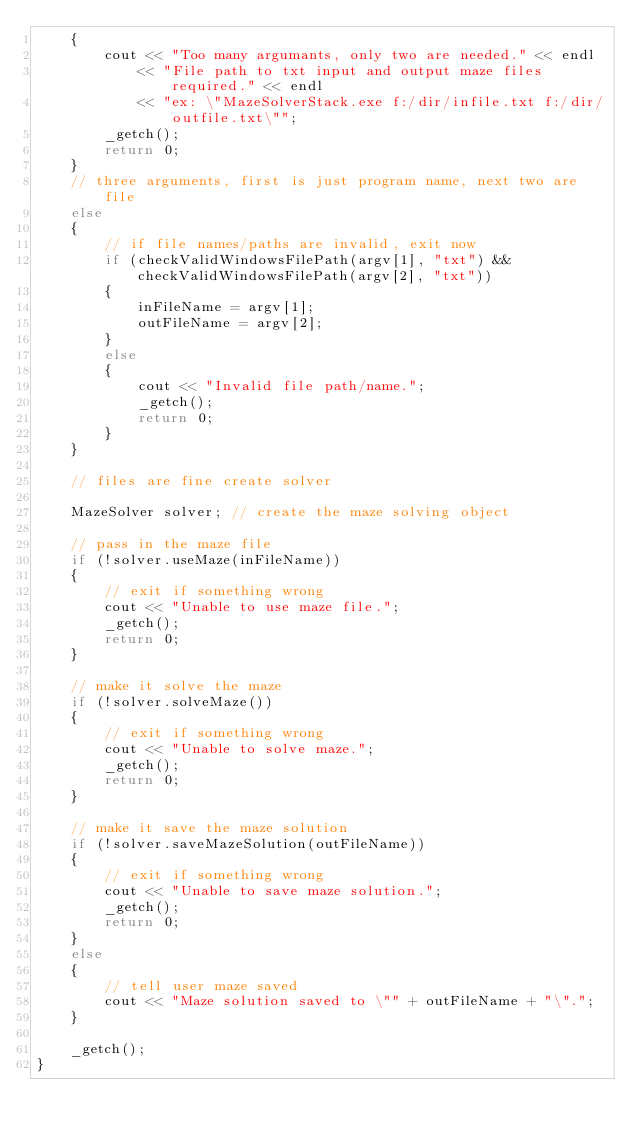<code> <loc_0><loc_0><loc_500><loc_500><_C++_>	{
		cout << "Too many argumants, only two are needed." << endl
			<< "File path to txt input and output maze files required." << endl
			<< "ex: \"MazeSolverStack.exe f:/dir/infile.txt f:/dir/outfile.txt\"";
		_getch();
		return 0;
	}
	// three arguments, first is just program name, next two are file
	else
	{
		// if file names/paths are invalid, exit now
		if (checkValidWindowsFilePath(argv[1], "txt") && checkValidWindowsFilePath(argv[2], "txt"))
		{
			inFileName = argv[1];
			outFileName = argv[2];
		}
		else
		{
			cout << "Invalid file path/name.";
			_getch();
			return 0;
		}
	}

	// files are fine create solver

	MazeSolver solver; // create the maze solving object

	// pass in the maze file
	if (!solver.useMaze(inFileName))
	{
		// exit if something wrong
		cout << "Unable to use maze file.";
		_getch();
		return 0;
	}

	// make it solve the maze
	if (!solver.solveMaze())
	{
		// exit if something wrong
		cout << "Unable to solve maze.";
		_getch();
		return 0;
	}

	// make it save the maze solution
	if (!solver.saveMazeSolution(outFileName))
	{
		// exit if something wrong
		cout << "Unable to save maze solution.";
		_getch();
		return 0;
	}
	else
	{
		// tell user maze saved
		cout << "Maze solution saved to \"" + outFileName + "\".";
	}

	_getch();
}</code> 